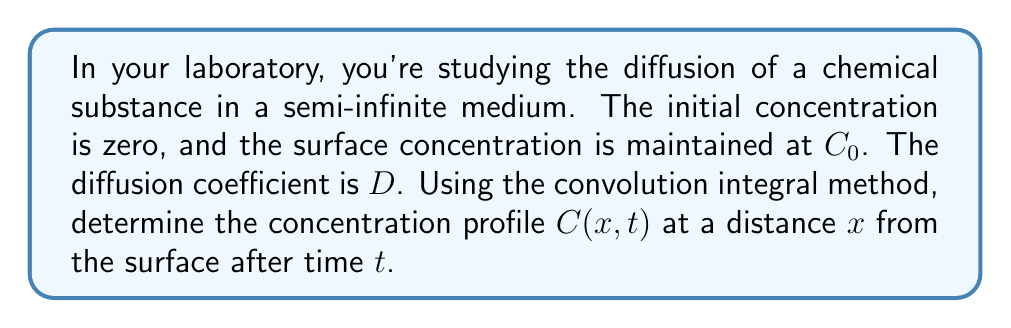Teach me how to tackle this problem. Let's approach this step-by-step:

1) The diffusion equation in one dimension is:

   $$\frac{\partial C}{\partial t} = D \frac{\partial^2 C}{\partial x^2}$$

2) For a semi-infinite medium with a constant surface concentration, the solution can be expressed as a convolution integral:

   $$C(x,t) = C_0 \int_0^t G(x,t-\tau) d\tau$$

   where $G(x,t)$ is the Green's function (or fundamental solution) for the diffusion equation.

3) The Green's function for the semi-infinite medium is:

   $$G(x,t) = \frac{1}{\sqrt{4\pi Dt}} \exp\left(-\frac{x^2}{4Dt}\right)$$

4) Substituting this into our convolution integral:

   $$C(x,t) = C_0 \int_0^t \frac{1}{\sqrt{4\pi D(t-\tau)}} \exp\left(-\frac{x^2}{4D(t-\tau)}\right) d\tau$$

5) To solve this, we make a change of variable. Let $u = \frac{x}{\sqrt{4D(t-\tau)}}$. Then:

   $$\tau = t - \frac{x^2}{4Du^2}$$
   $$d\tau = \frac{x^2}{2Du^3} du$$

6) When $\tau = 0$, $u = \frac{x}{\sqrt{4Dt}}$, and when $\tau = t$, $u \to \infty$.

7) Substituting these into our integral:

   $$C(x,t) = \frac{2C_0}{\sqrt{\pi}} \int_{\frac{x}{\sqrt{4Dt}}}^{\infty} e^{-u^2} du$$

8) The integral in step 7 is the complementary error function, erfc:

   $$C(x,t) = C_0 \cdot \text{erfc}\left(\frac{x}{\sqrt{4Dt}}\right)$$

This is the concentration profile of the diffusing substance.
Answer: $C(x,t) = C_0 \cdot \text{erfc}\left(\frac{x}{\sqrt{4Dt}}\right)$ 